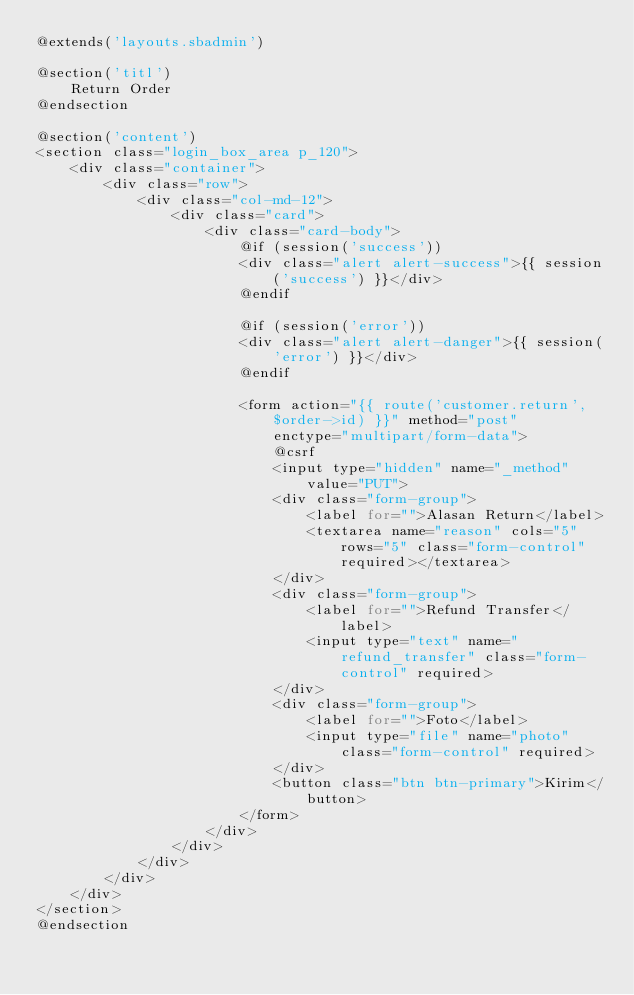Convert code to text. <code><loc_0><loc_0><loc_500><loc_500><_PHP_>@extends('layouts.sbadmin')

@section('titl')
    Return Order
@endsection

@section('content')
<section class="login_box_area p_120">
    <div class="container">
        <div class="row">
            <div class="col-md-12">
                <div class="card">
                    <div class="card-body">
                        @if (session('success'))
                        <div class="alert alert-success">{{ session('success') }}</div>
                        @endif

                        @if (session('error'))
                        <div class="alert alert-danger">{{ session('error') }}</div>
                        @endif

                        <form action="{{ route('customer.return', $order->id) }}" method="post"
                            enctype="multipart/form-data">
                            @csrf
                            <input type="hidden" name="_method" value="PUT">
                            <div class="form-group">
                                <label for="">Alasan Return</label>
                                <textarea name="reason" cols="5" rows="5" class="form-control" required></textarea>
                            </div>
                            <div class="form-group">
                                <label for="">Refund Transfer</label>
                                <input type="text" name="refund_transfer" class="form-control" required>
                            </div>
                            <div class="form-group">
                                <label for="">Foto</label>
                                <input type="file" name="photo" class="form-control" required>
                            </div>
                            <button class="btn btn-primary">Kirim</button>
                        </form>
                    </div>
                </div>
            </div>
        </div>
    </div>
</section>
@endsection</code> 